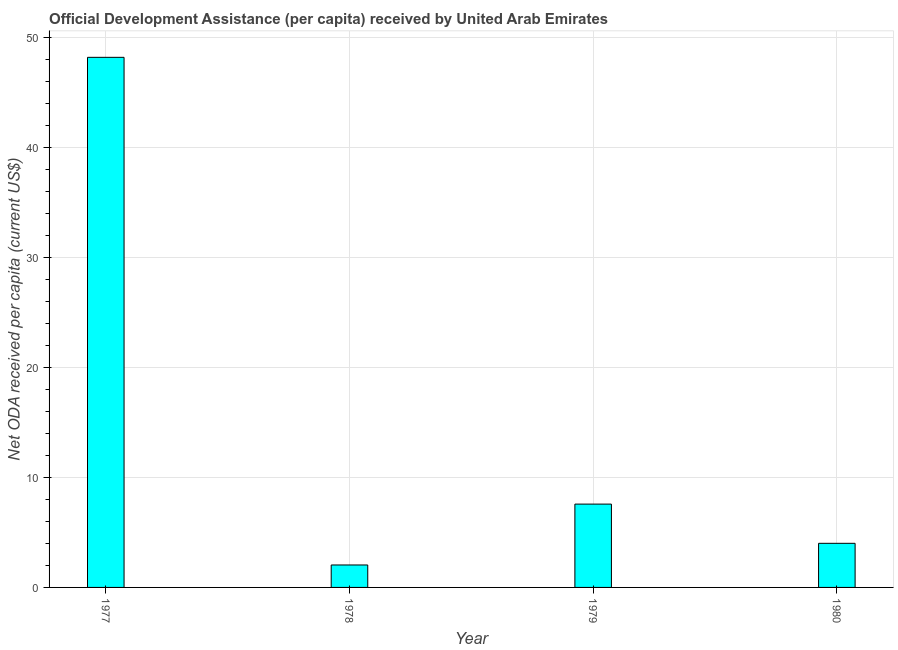What is the title of the graph?
Your answer should be very brief. Official Development Assistance (per capita) received by United Arab Emirates. What is the label or title of the Y-axis?
Offer a very short reply. Net ODA received per capita (current US$). What is the net oda received per capita in 1979?
Offer a terse response. 7.58. Across all years, what is the maximum net oda received per capita?
Give a very brief answer. 48.23. Across all years, what is the minimum net oda received per capita?
Ensure brevity in your answer.  2.04. In which year was the net oda received per capita minimum?
Make the answer very short. 1978. What is the sum of the net oda received per capita?
Offer a very short reply. 61.86. What is the difference between the net oda received per capita in 1977 and 1978?
Offer a terse response. 46.18. What is the average net oda received per capita per year?
Provide a short and direct response. 15.47. What is the median net oda received per capita?
Offer a very short reply. 5.8. In how many years, is the net oda received per capita greater than 36 US$?
Provide a succinct answer. 1. Do a majority of the years between 1977 and 1980 (inclusive) have net oda received per capita greater than 20 US$?
Keep it short and to the point. No. What is the ratio of the net oda received per capita in 1977 to that in 1978?
Make the answer very short. 23.61. Is the net oda received per capita in 1978 less than that in 1980?
Your answer should be compact. Yes. What is the difference between the highest and the second highest net oda received per capita?
Give a very brief answer. 40.65. Is the sum of the net oda received per capita in 1977 and 1979 greater than the maximum net oda received per capita across all years?
Make the answer very short. Yes. What is the difference between the highest and the lowest net oda received per capita?
Your response must be concise. 46.18. How many bars are there?
Ensure brevity in your answer.  4. Are all the bars in the graph horizontal?
Give a very brief answer. No. How many years are there in the graph?
Provide a succinct answer. 4. What is the Net ODA received per capita (current US$) of 1977?
Offer a terse response. 48.23. What is the Net ODA received per capita (current US$) of 1978?
Provide a succinct answer. 2.04. What is the Net ODA received per capita (current US$) in 1979?
Your answer should be very brief. 7.58. What is the Net ODA received per capita (current US$) of 1980?
Offer a very short reply. 4.01. What is the difference between the Net ODA received per capita (current US$) in 1977 and 1978?
Your answer should be very brief. 46.18. What is the difference between the Net ODA received per capita (current US$) in 1977 and 1979?
Your answer should be compact. 40.64. What is the difference between the Net ODA received per capita (current US$) in 1977 and 1980?
Keep it short and to the point. 44.21. What is the difference between the Net ODA received per capita (current US$) in 1978 and 1979?
Your response must be concise. -5.54. What is the difference between the Net ODA received per capita (current US$) in 1978 and 1980?
Provide a succinct answer. -1.97. What is the difference between the Net ODA received per capita (current US$) in 1979 and 1980?
Your response must be concise. 3.57. What is the ratio of the Net ODA received per capita (current US$) in 1977 to that in 1978?
Ensure brevity in your answer.  23.61. What is the ratio of the Net ODA received per capita (current US$) in 1977 to that in 1979?
Provide a short and direct response. 6.36. What is the ratio of the Net ODA received per capita (current US$) in 1977 to that in 1980?
Ensure brevity in your answer.  12.02. What is the ratio of the Net ODA received per capita (current US$) in 1978 to that in 1979?
Ensure brevity in your answer.  0.27. What is the ratio of the Net ODA received per capita (current US$) in 1978 to that in 1980?
Keep it short and to the point. 0.51. What is the ratio of the Net ODA received per capita (current US$) in 1979 to that in 1980?
Give a very brief answer. 1.89. 